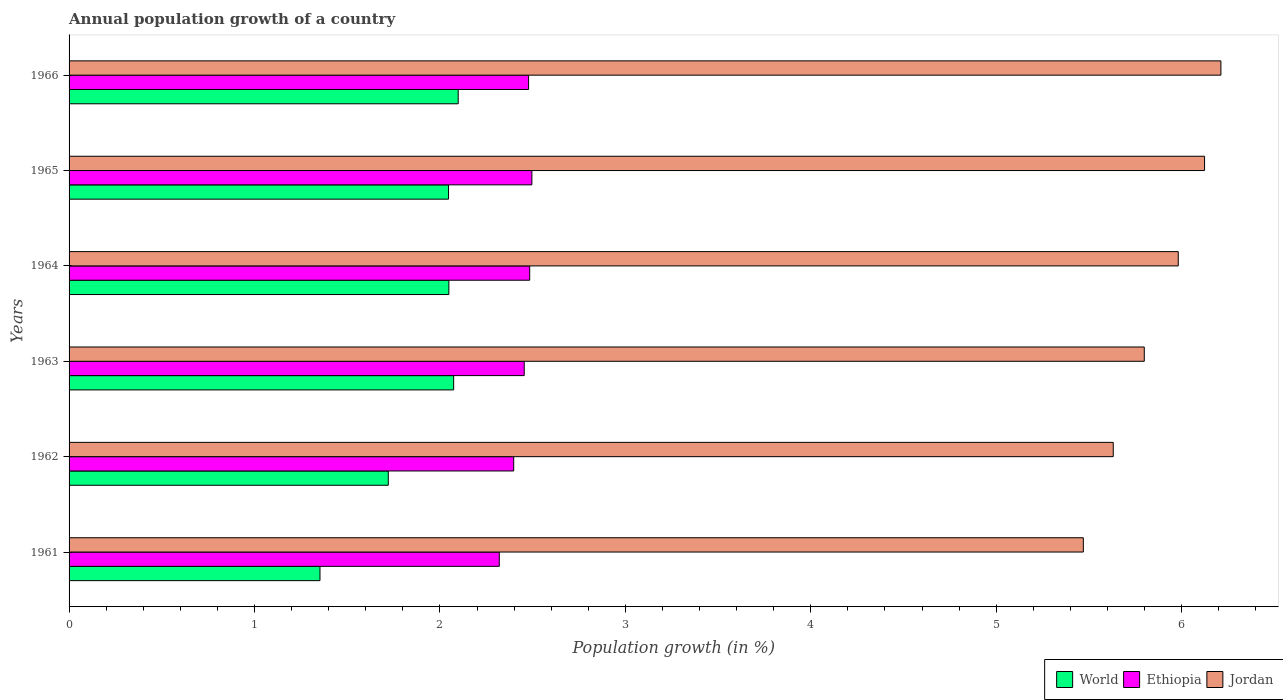How many different coloured bars are there?
Make the answer very short. 3. How many groups of bars are there?
Provide a short and direct response. 6. Are the number of bars on each tick of the Y-axis equal?
Your answer should be compact. Yes. What is the annual population growth in World in 1962?
Your answer should be compact. 1.72. Across all years, what is the maximum annual population growth in World?
Make the answer very short. 2.1. Across all years, what is the minimum annual population growth in Jordan?
Your answer should be very brief. 5.47. In which year was the annual population growth in Jordan maximum?
Provide a short and direct response. 1966. In which year was the annual population growth in Ethiopia minimum?
Your response must be concise. 1961. What is the total annual population growth in Ethiopia in the graph?
Offer a terse response. 14.63. What is the difference between the annual population growth in World in 1963 and that in 1964?
Give a very brief answer. 0.03. What is the difference between the annual population growth in Ethiopia in 1962 and the annual population growth in World in 1966?
Offer a very short reply. 0.3. What is the average annual population growth in Ethiopia per year?
Your response must be concise. 2.44. In the year 1964, what is the difference between the annual population growth in Ethiopia and annual population growth in Jordan?
Ensure brevity in your answer.  -3.5. In how many years, is the annual population growth in Ethiopia greater than 0.4 %?
Give a very brief answer. 6. What is the ratio of the annual population growth in Jordan in 1962 to that in 1964?
Give a very brief answer. 0.94. Is the annual population growth in Ethiopia in 1962 less than that in 1965?
Offer a terse response. Yes. What is the difference between the highest and the second highest annual population growth in World?
Your response must be concise. 0.02. What is the difference between the highest and the lowest annual population growth in World?
Your answer should be compact. 0.75. What does the 1st bar from the top in 1962 represents?
Offer a terse response. Jordan. What does the 1st bar from the bottom in 1963 represents?
Your answer should be compact. World. What is the difference between two consecutive major ticks on the X-axis?
Make the answer very short. 1. Does the graph contain grids?
Make the answer very short. No. Where does the legend appear in the graph?
Make the answer very short. Bottom right. What is the title of the graph?
Keep it short and to the point. Annual population growth of a country. Does "Seychelles" appear as one of the legend labels in the graph?
Your answer should be very brief. No. What is the label or title of the X-axis?
Ensure brevity in your answer.  Population growth (in %). What is the Population growth (in %) of World in 1961?
Offer a terse response. 1.35. What is the Population growth (in %) of Ethiopia in 1961?
Keep it short and to the point. 2.32. What is the Population growth (in %) in Jordan in 1961?
Provide a succinct answer. 5.47. What is the Population growth (in %) in World in 1962?
Your answer should be compact. 1.72. What is the Population growth (in %) in Ethiopia in 1962?
Your answer should be compact. 2.4. What is the Population growth (in %) of Jordan in 1962?
Offer a very short reply. 5.63. What is the Population growth (in %) of World in 1963?
Provide a short and direct response. 2.07. What is the Population growth (in %) of Ethiopia in 1963?
Give a very brief answer. 2.45. What is the Population growth (in %) of Jordan in 1963?
Offer a terse response. 5.8. What is the Population growth (in %) in World in 1964?
Provide a succinct answer. 2.05. What is the Population growth (in %) of Ethiopia in 1964?
Give a very brief answer. 2.48. What is the Population growth (in %) in Jordan in 1964?
Make the answer very short. 5.98. What is the Population growth (in %) in World in 1965?
Offer a very short reply. 2.05. What is the Population growth (in %) of Ethiopia in 1965?
Give a very brief answer. 2.5. What is the Population growth (in %) of Jordan in 1965?
Offer a very short reply. 6.12. What is the Population growth (in %) of World in 1966?
Keep it short and to the point. 2.1. What is the Population growth (in %) of Ethiopia in 1966?
Your answer should be very brief. 2.48. What is the Population growth (in %) in Jordan in 1966?
Keep it short and to the point. 6.21. Across all years, what is the maximum Population growth (in %) in World?
Provide a succinct answer. 2.1. Across all years, what is the maximum Population growth (in %) of Ethiopia?
Give a very brief answer. 2.5. Across all years, what is the maximum Population growth (in %) of Jordan?
Ensure brevity in your answer.  6.21. Across all years, what is the minimum Population growth (in %) of World?
Your answer should be compact. 1.35. Across all years, what is the minimum Population growth (in %) of Ethiopia?
Give a very brief answer. 2.32. Across all years, what is the minimum Population growth (in %) of Jordan?
Your response must be concise. 5.47. What is the total Population growth (in %) in World in the graph?
Your answer should be very brief. 11.34. What is the total Population growth (in %) in Ethiopia in the graph?
Your answer should be very brief. 14.63. What is the total Population growth (in %) of Jordan in the graph?
Make the answer very short. 35.22. What is the difference between the Population growth (in %) of World in 1961 and that in 1962?
Offer a terse response. -0.37. What is the difference between the Population growth (in %) in Ethiopia in 1961 and that in 1962?
Your answer should be very brief. -0.08. What is the difference between the Population growth (in %) of Jordan in 1961 and that in 1962?
Your response must be concise. -0.16. What is the difference between the Population growth (in %) in World in 1961 and that in 1963?
Your answer should be very brief. -0.72. What is the difference between the Population growth (in %) of Ethiopia in 1961 and that in 1963?
Keep it short and to the point. -0.13. What is the difference between the Population growth (in %) in Jordan in 1961 and that in 1963?
Your answer should be very brief. -0.33. What is the difference between the Population growth (in %) in World in 1961 and that in 1964?
Your response must be concise. -0.69. What is the difference between the Population growth (in %) of Ethiopia in 1961 and that in 1964?
Provide a short and direct response. -0.16. What is the difference between the Population growth (in %) in Jordan in 1961 and that in 1964?
Your response must be concise. -0.51. What is the difference between the Population growth (in %) of World in 1961 and that in 1965?
Make the answer very short. -0.69. What is the difference between the Population growth (in %) of Ethiopia in 1961 and that in 1965?
Provide a short and direct response. -0.18. What is the difference between the Population growth (in %) of Jordan in 1961 and that in 1965?
Offer a very short reply. -0.65. What is the difference between the Population growth (in %) in World in 1961 and that in 1966?
Provide a short and direct response. -0.75. What is the difference between the Population growth (in %) of Ethiopia in 1961 and that in 1966?
Provide a short and direct response. -0.16. What is the difference between the Population growth (in %) of Jordan in 1961 and that in 1966?
Provide a short and direct response. -0.74. What is the difference between the Population growth (in %) of World in 1962 and that in 1963?
Ensure brevity in your answer.  -0.35. What is the difference between the Population growth (in %) of Ethiopia in 1962 and that in 1963?
Provide a succinct answer. -0.06. What is the difference between the Population growth (in %) in Jordan in 1962 and that in 1963?
Your response must be concise. -0.17. What is the difference between the Population growth (in %) of World in 1962 and that in 1964?
Provide a short and direct response. -0.33. What is the difference between the Population growth (in %) in Ethiopia in 1962 and that in 1964?
Make the answer very short. -0.09. What is the difference between the Population growth (in %) of Jordan in 1962 and that in 1964?
Offer a terse response. -0.35. What is the difference between the Population growth (in %) in World in 1962 and that in 1965?
Provide a succinct answer. -0.32. What is the difference between the Population growth (in %) of Ethiopia in 1962 and that in 1965?
Your response must be concise. -0.1. What is the difference between the Population growth (in %) in Jordan in 1962 and that in 1965?
Provide a short and direct response. -0.49. What is the difference between the Population growth (in %) of World in 1962 and that in 1966?
Offer a terse response. -0.38. What is the difference between the Population growth (in %) of Ethiopia in 1962 and that in 1966?
Provide a short and direct response. -0.08. What is the difference between the Population growth (in %) in Jordan in 1962 and that in 1966?
Give a very brief answer. -0.58. What is the difference between the Population growth (in %) of World in 1963 and that in 1964?
Offer a very short reply. 0.03. What is the difference between the Population growth (in %) of Ethiopia in 1963 and that in 1964?
Offer a very short reply. -0.03. What is the difference between the Population growth (in %) in Jordan in 1963 and that in 1964?
Make the answer very short. -0.18. What is the difference between the Population growth (in %) of World in 1963 and that in 1965?
Provide a short and direct response. 0.03. What is the difference between the Population growth (in %) of Ethiopia in 1963 and that in 1965?
Your response must be concise. -0.04. What is the difference between the Population growth (in %) in Jordan in 1963 and that in 1965?
Ensure brevity in your answer.  -0.33. What is the difference between the Population growth (in %) of World in 1963 and that in 1966?
Your answer should be compact. -0.02. What is the difference between the Population growth (in %) in Ethiopia in 1963 and that in 1966?
Offer a terse response. -0.02. What is the difference between the Population growth (in %) of Jordan in 1963 and that in 1966?
Keep it short and to the point. -0.41. What is the difference between the Population growth (in %) in World in 1964 and that in 1965?
Your answer should be compact. 0. What is the difference between the Population growth (in %) of Ethiopia in 1964 and that in 1965?
Ensure brevity in your answer.  -0.01. What is the difference between the Population growth (in %) in Jordan in 1964 and that in 1965?
Your response must be concise. -0.14. What is the difference between the Population growth (in %) of World in 1964 and that in 1966?
Ensure brevity in your answer.  -0.05. What is the difference between the Population growth (in %) in Ethiopia in 1964 and that in 1966?
Give a very brief answer. 0.01. What is the difference between the Population growth (in %) of Jordan in 1964 and that in 1966?
Ensure brevity in your answer.  -0.23. What is the difference between the Population growth (in %) of World in 1965 and that in 1966?
Keep it short and to the point. -0.05. What is the difference between the Population growth (in %) of Ethiopia in 1965 and that in 1966?
Offer a terse response. 0.02. What is the difference between the Population growth (in %) of Jordan in 1965 and that in 1966?
Provide a short and direct response. -0.09. What is the difference between the Population growth (in %) of World in 1961 and the Population growth (in %) of Ethiopia in 1962?
Your answer should be very brief. -1.04. What is the difference between the Population growth (in %) of World in 1961 and the Population growth (in %) of Jordan in 1962?
Offer a terse response. -4.28. What is the difference between the Population growth (in %) of Ethiopia in 1961 and the Population growth (in %) of Jordan in 1962?
Keep it short and to the point. -3.31. What is the difference between the Population growth (in %) of World in 1961 and the Population growth (in %) of Ethiopia in 1963?
Offer a terse response. -1.1. What is the difference between the Population growth (in %) in World in 1961 and the Population growth (in %) in Jordan in 1963?
Give a very brief answer. -4.45. What is the difference between the Population growth (in %) of Ethiopia in 1961 and the Population growth (in %) of Jordan in 1963?
Keep it short and to the point. -3.48. What is the difference between the Population growth (in %) of World in 1961 and the Population growth (in %) of Ethiopia in 1964?
Your response must be concise. -1.13. What is the difference between the Population growth (in %) of World in 1961 and the Population growth (in %) of Jordan in 1964?
Provide a succinct answer. -4.63. What is the difference between the Population growth (in %) of Ethiopia in 1961 and the Population growth (in %) of Jordan in 1964?
Keep it short and to the point. -3.66. What is the difference between the Population growth (in %) in World in 1961 and the Population growth (in %) in Ethiopia in 1965?
Offer a very short reply. -1.14. What is the difference between the Population growth (in %) in World in 1961 and the Population growth (in %) in Jordan in 1965?
Provide a succinct answer. -4.77. What is the difference between the Population growth (in %) of Ethiopia in 1961 and the Population growth (in %) of Jordan in 1965?
Provide a short and direct response. -3.8. What is the difference between the Population growth (in %) of World in 1961 and the Population growth (in %) of Ethiopia in 1966?
Keep it short and to the point. -1.12. What is the difference between the Population growth (in %) in World in 1961 and the Population growth (in %) in Jordan in 1966?
Your answer should be very brief. -4.86. What is the difference between the Population growth (in %) of Ethiopia in 1961 and the Population growth (in %) of Jordan in 1966?
Provide a short and direct response. -3.89. What is the difference between the Population growth (in %) in World in 1962 and the Population growth (in %) in Ethiopia in 1963?
Your answer should be very brief. -0.73. What is the difference between the Population growth (in %) of World in 1962 and the Population growth (in %) of Jordan in 1963?
Make the answer very short. -4.08. What is the difference between the Population growth (in %) of Ethiopia in 1962 and the Population growth (in %) of Jordan in 1963?
Give a very brief answer. -3.4. What is the difference between the Population growth (in %) in World in 1962 and the Population growth (in %) in Ethiopia in 1964?
Keep it short and to the point. -0.76. What is the difference between the Population growth (in %) in World in 1962 and the Population growth (in %) in Jordan in 1964?
Give a very brief answer. -4.26. What is the difference between the Population growth (in %) of Ethiopia in 1962 and the Population growth (in %) of Jordan in 1964?
Provide a short and direct response. -3.58. What is the difference between the Population growth (in %) in World in 1962 and the Population growth (in %) in Ethiopia in 1965?
Keep it short and to the point. -0.77. What is the difference between the Population growth (in %) in World in 1962 and the Population growth (in %) in Jordan in 1965?
Provide a succinct answer. -4.4. What is the difference between the Population growth (in %) in Ethiopia in 1962 and the Population growth (in %) in Jordan in 1965?
Keep it short and to the point. -3.73. What is the difference between the Population growth (in %) in World in 1962 and the Population growth (in %) in Ethiopia in 1966?
Your answer should be very brief. -0.76. What is the difference between the Population growth (in %) in World in 1962 and the Population growth (in %) in Jordan in 1966?
Your response must be concise. -4.49. What is the difference between the Population growth (in %) of Ethiopia in 1962 and the Population growth (in %) of Jordan in 1966?
Your answer should be compact. -3.81. What is the difference between the Population growth (in %) in World in 1963 and the Population growth (in %) in Ethiopia in 1964?
Offer a very short reply. -0.41. What is the difference between the Population growth (in %) of World in 1963 and the Population growth (in %) of Jordan in 1964?
Give a very brief answer. -3.91. What is the difference between the Population growth (in %) in Ethiopia in 1963 and the Population growth (in %) in Jordan in 1964?
Make the answer very short. -3.53. What is the difference between the Population growth (in %) of World in 1963 and the Population growth (in %) of Ethiopia in 1965?
Ensure brevity in your answer.  -0.42. What is the difference between the Population growth (in %) in World in 1963 and the Population growth (in %) in Jordan in 1965?
Ensure brevity in your answer.  -4.05. What is the difference between the Population growth (in %) of Ethiopia in 1963 and the Population growth (in %) of Jordan in 1965?
Ensure brevity in your answer.  -3.67. What is the difference between the Population growth (in %) of World in 1963 and the Population growth (in %) of Ethiopia in 1966?
Your answer should be compact. -0.4. What is the difference between the Population growth (in %) of World in 1963 and the Population growth (in %) of Jordan in 1966?
Keep it short and to the point. -4.14. What is the difference between the Population growth (in %) of Ethiopia in 1963 and the Population growth (in %) of Jordan in 1966?
Make the answer very short. -3.76. What is the difference between the Population growth (in %) in World in 1964 and the Population growth (in %) in Ethiopia in 1965?
Ensure brevity in your answer.  -0.45. What is the difference between the Population growth (in %) of World in 1964 and the Population growth (in %) of Jordan in 1965?
Make the answer very short. -4.08. What is the difference between the Population growth (in %) in Ethiopia in 1964 and the Population growth (in %) in Jordan in 1965?
Offer a terse response. -3.64. What is the difference between the Population growth (in %) of World in 1964 and the Population growth (in %) of Ethiopia in 1966?
Your answer should be very brief. -0.43. What is the difference between the Population growth (in %) of World in 1964 and the Population growth (in %) of Jordan in 1966?
Give a very brief answer. -4.16. What is the difference between the Population growth (in %) in Ethiopia in 1964 and the Population growth (in %) in Jordan in 1966?
Give a very brief answer. -3.73. What is the difference between the Population growth (in %) of World in 1965 and the Population growth (in %) of Ethiopia in 1966?
Your response must be concise. -0.43. What is the difference between the Population growth (in %) in World in 1965 and the Population growth (in %) in Jordan in 1966?
Provide a succinct answer. -4.17. What is the difference between the Population growth (in %) of Ethiopia in 1965 and the Population growth (in %) of Jordan in 1966?
Provide a succinct answer. -3.72. What is the average Population growth (in %) of World per year?
Give a very brief answer. 1.89. What is the average Population growth (in %) of Ethiopia per year?
Give a very brief answer. 2.44. What is the average Population growth (in %) of Jordan per year?
Provide a short and direct response. 5.87. In the year 1961, what is the difference between the Population growth (in %) of World and Population growth (in %) of Ethiopia?
Offer a very short reply. -0.97. In the year 1961, what is the difference between the Population growth (in %) of World and Population growth (in %) of Jordan?
Offer a very short reply. -4.12. In the year 1961, what is the difference between the Population growth (in %) in Ethiopia and Population growth (in %) in Jordan?
Make the answer very short. -3.15. In the year 1962, what is the difference between the Population growth (in %) in World and Population growth (in %) in Ethiopia?
Make the answer very short. -0.68. In the year 1962, what is the difference between the Population growth (in %) in World and Population growth (in %) in Jordan?
Keep it short and to the point. -3.91. In the year 1962, what is the difference between the Population growth (in %) of Ethiopia and Population growth (in %) of Jordan?
Ensure brevity in your answer.  -3.23. In the year 1963, what is the difference between the Population growth (in %) in World and Population growth (in %) in Ethiopia?
Ensure brevity in your answer.  -0.38. In the year 1963, what is the difference between the Population growth (in %) of World and Population growth (in %) of Jordan?
Provide a short and direct response. -3.72. In the year 1963, what is the difference between the Population growth (in %) of Ethiopia and Population growth (in %) of Jordan?
Provide a short and direct response. -3.34. In the year 1964, what is the difference between the Population growth (in %) in World and Population growth (in %) in Ethiopia?
Your answer should be compact. -0.44. In the year 1964, what is the difference between the Population growth (in %) of World and Population growth (in %) of Jordan?
Provide a succinct answer. -3.93. In the year 1964, what is the difference between the Population growth (in %) of Ethiopia and Population growth (in %) of Jordan?
Make the answer very short. -3.5. In the year 1965, what is the difference between the Population growth (in %) in World and Population growth (in %) in Ethiopia?
Ensure brevity in your answer.  -0.45. In the year 1965, what is the difference between the Population growth (in %) of World and Population growth (in %) of Jordan?
Keep it short and to the point. -4.08. In the year 1965, what is the difference between the Population growth (in %) in Ethiopia and Population growth (in %) in Jordan?
Your response must be concise. -3.63. In the year 1966, what is the difference between the Population growth (in %) of World and Population growth (in %) of Ethiopia?
Your answer should be very brief. -0.38. In the year 1966, what is the difference between the Population growth (in %) of World and Population growth (in %) of Jordan?
Provide a short and direct response. -4.11. In the year 1966, what is the difference between the Population growth (in %) in Ethiopia and Population growth (in %) in Jordan?
Keep it short and to the point. -3.73. What is the ratio of the Population growth (in %) in World in 1961 to that in 1962?
Provide a succinct answer. 0.79. What is the ratio of the Population growth (in %) in Ethiopia in 1961 to that in 1962?
Offer a very short reply. 0.97. What is the ratio of the Population growth (in %) of Jordan in 1961 to that in 1962?
Offer a very short reply. 0.97. What is the ratio of the Population growth (in %) of World in 1961 to that in 1963?
Provide a short and direct response. 0.65. What is the ratio of the Population growth (in %) in Ethiopia in 1961 to that in 1963?
Give a very brief answer. 0.95. What is the ratio of the Population growth (in %) in Jordan in 1961 to that in 1963?
Ensure brevity in your answer.  0.94. What is the ratio of the Population growth (in %) of World in 1961 to that in 1964?
Provide a succinct answer. 0.66. What is the ratio of the Population growth (in %) in Ethiopia in 1961 to that in 1964?
Ensure brevity in your answer.  0.93. What is the ratio of the Population growth (in %) in Jordan in 1961 to that in 1964?
Offer a very short reply. 0.91. What is the ratio of the Population growth (in %) in World in 1961 to that in 1965?
Your response must be concise. 0.66. What is the ratio of the Population growth (in %) in Ethiopia in 1961 to that in 1965?
Give a very brief answer. 0.93. What is the ratio of the Population growth (in %) of Jordan in 1961 to that in 1965?
Offer a very short reply. 0.89. What is the ratio of the Population growth (in %) in World in 1961 to that in 1966?
Provide a succinct answer. 0.64. What is the ratio of the Population growth (in %) of Ethiopia in 1961 to that in 1966?
Keep it short and to the point. 0.94. What is the ratio of the Population growth (in %) in Jordan in 1961 to that in 1966?
Give a very brief answer. 0.88. What is the ratio of the Population growth (in %) of World in 1962 to that in 1963?
Provide a short and direct response. 0.83. What is the ratio of the Population growth (in %) of Ethiopia in 1962 to that in 1963?
Give a very brief answer. 0.98. What is the ratio of the Population growth (in %) of Jordan in 1962 to that in 1963?
Your answer should be very brief. 0.97. What is the ratio of the Population growth (in %) in World in 1962 to that in 1964?
Give a very brief answer. 0.84. What is the ratio of the Population growth (in %) of Ethiopia in 1962 to that in 1964?
Offer a terse response. 0.97. What is the ratio of the Population growth (in %) in Jordan in 1962 to that in 1964?
Keep it short and to the point. 0.94. What is the ratio of the Population growth (in %) in World in 1962 to that in 1965?
Make the answer very short. 0.84. What is the ratio of the Population growth (in %) in Ethiopia in 1962 to that in 1965?
Give a very brief answer. 0.96. What is the ratio of the Population growth (in %) in Jordan in 1962 to that in 1965?
Ensure brevity in your answer.  0.92. What is the ratio of the Population growth (in %) of World in 1962 to that in 1966?
Your answer should be compact. 0.82. What is the ratio of the Population growth (in %) of Ethiopia in 1962 to that in 1966?
Make the answer very short. 0.97. What is the ratio of the Population growth (in %) in Jordan in 1962 to that in 1966?
Provide a succinct answer. 0.91. What is the ratio of the Population growth (in %) in World in 1963 to that in 1964?
Make the answer very short. 1.01. What is the ratio of the Population growth (in %) of Jordan in 1963 to that in 1964?
Your response must be concise. 0.97. What is the ratio of the Population growth (in %) of World in 1963 to that in 1965?
Provide a succinct answer. 1.01. What is the ratio of the Population growth (in %) in Ethiopia in 1963 to that in 1965?
Keep it short and to the point. 0.98. What is the ratio of the Population growth (in %) of Jordan in 1963 to that in 1965?
Provide a succinct answer. 0.95. What is the ratio of the Population growth (in %) in World in 1963 to that in 1966?
Your answer should be very brief. 0.99. What is the ratio of the Population growth (in %) in Ethiopia in 1963 to that in 1966?
Provide a succinct answer. 0.99. What is the ratio of the Population growth (in %) of Jordan in 1963 to that in 1966?
Keep it short and to the point. 0.93. What is the ratio of the Population growth (in %) of Jordan in 1964 to that in 1965?
Your answer should be compact. 0.98. What is the ratio of the Population growth (in %) of World in 1964 to that in 1966?
Give a very brief answer. 0.98. What is the ratio of the Population growth (in %) of World in 1965 to that in 1966?
Offer a terse response. 0.98. What is the ratio of the Population growth (in %) in Ethiopia in 1965 to that in 1966?
Provide a short and direct response. 1.01. What is the ratio of the Population growth (in %) in Jordan in 1965 to that in 1966?
Your answer should be very brief. 0.99. What is the difference between the highest and the second highest Population growth (in %) in World?
Keep it short and to the point. 0.02. What is the difference between the highest and the second highest Population growth (in %) in Ethiopia?
Provide a short and direct response. 0.01. What is the difference between the highest and the second highest Population growth (in %) of Jordan?
Your response must be concise. 0.09. What is the difference between the highest and the lowest Population growth (in %) of World?
Provide a short and direct response. 0.75. What is the difference between the highest and the lowest Population growth (in %) of Ethiopia?
Your answer should be very brief. 0.18. What is the difference between the highest and the lowest Population growth (in %) in Jordan?
Provide a short and direct response. 0.74. 